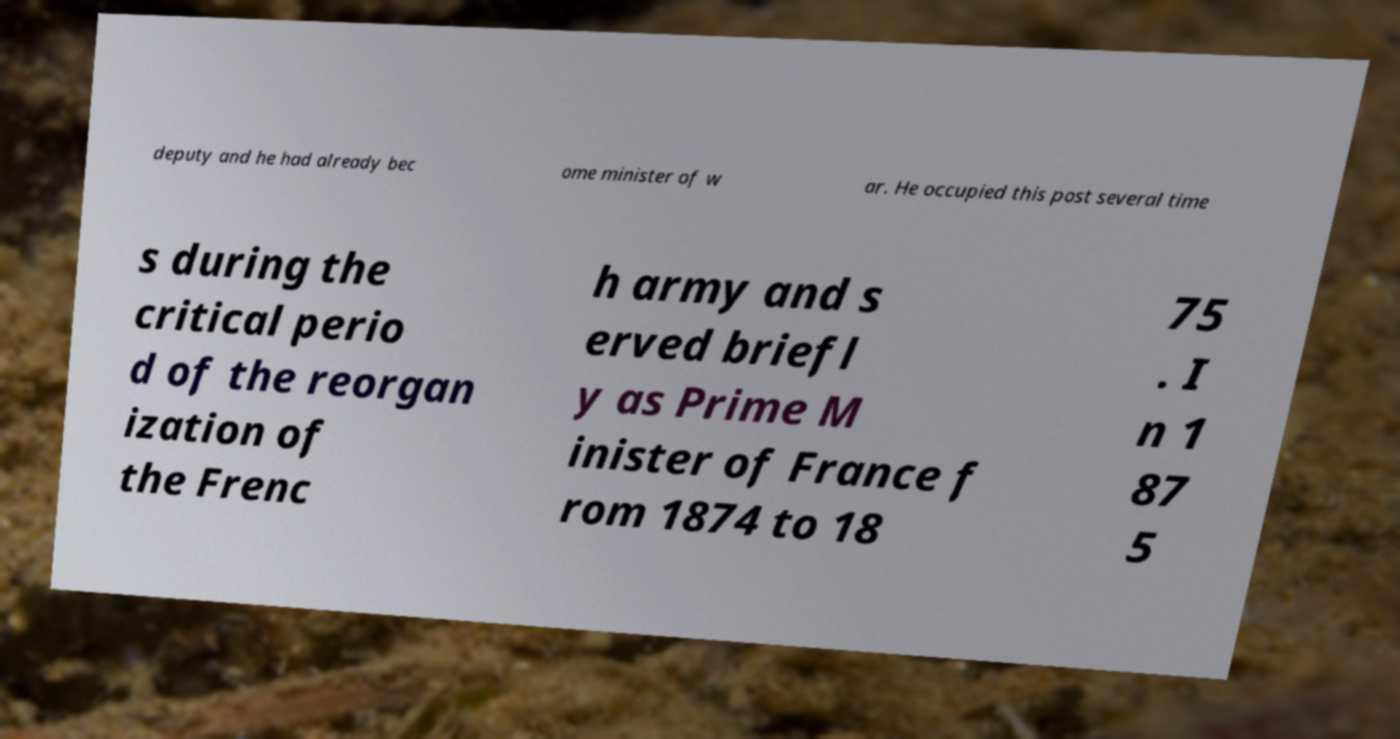What messages or text are displayed in this image? I need them in a readable, typed format. deputy and he had already bec ome minister of w ar. He occupied this post several time s during the critical perio d of the reorgan ization of the Frenc h army and s erved briefl y as Prime M inister of France f rom 1874 to 18 75 . I n 1 87 5 